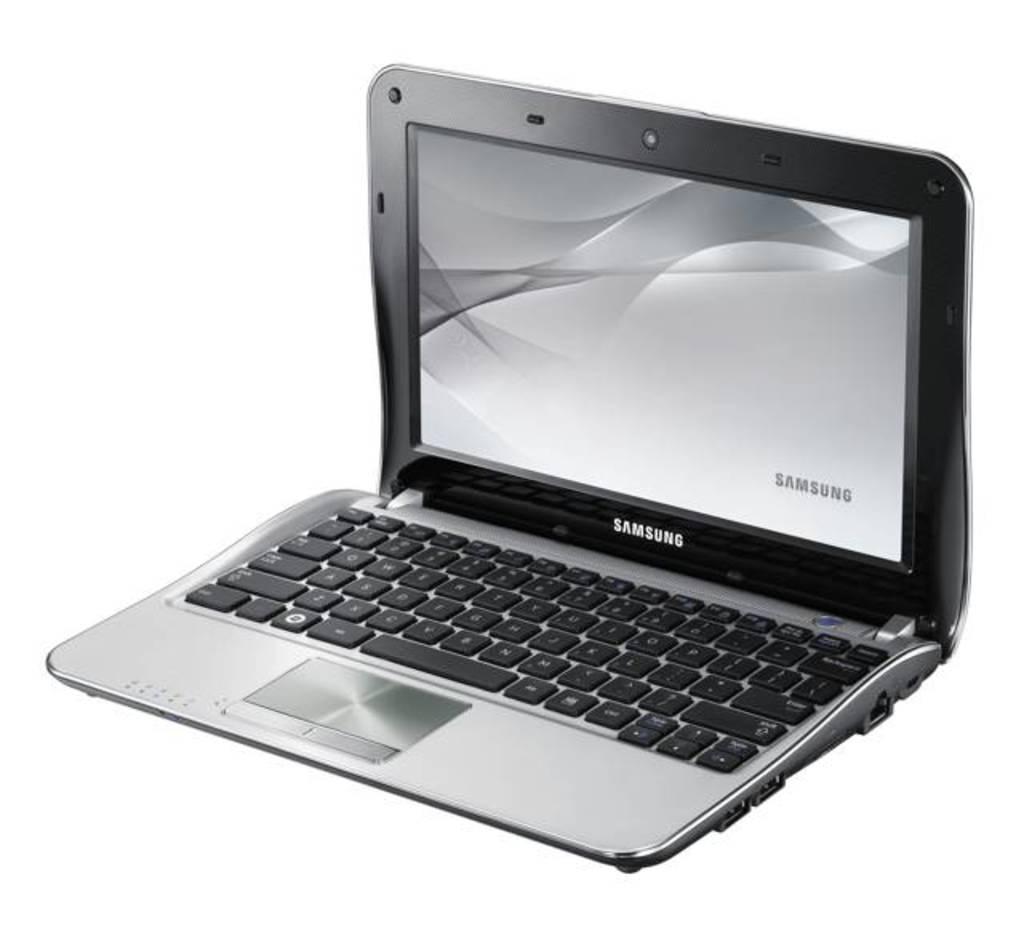Who makes this laptop?
Offer a very short reply. Samsung. What brand laptop is this?
Provide a succinct answer. Samsung. 